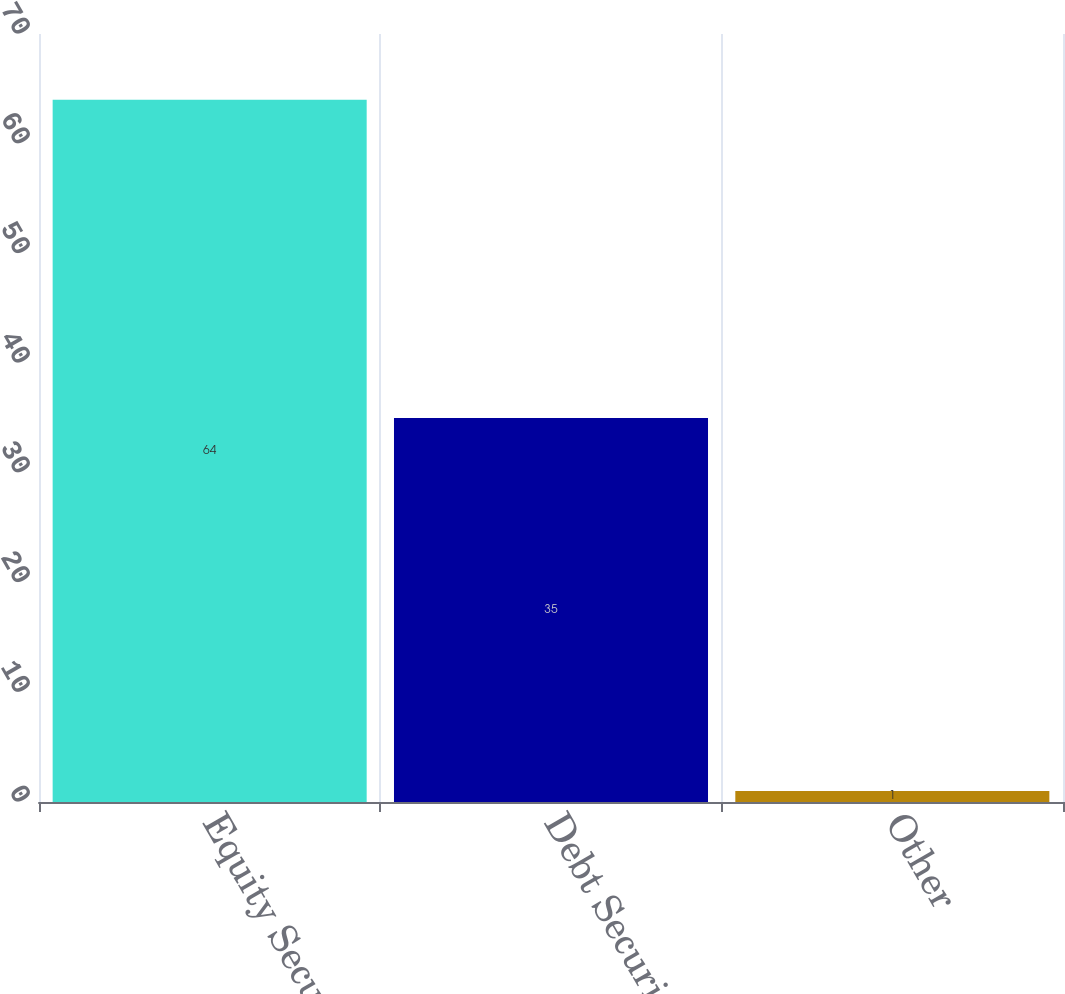Convert chart to OTSL. <chart><loc_0><loc_0><loc_500><loc_500><bar_chart><fcel>Equity Securities<fcel>Debt Securities<fcel>Other<nl><fcel>64<fcel>35<fcel>1<nl></chart> 